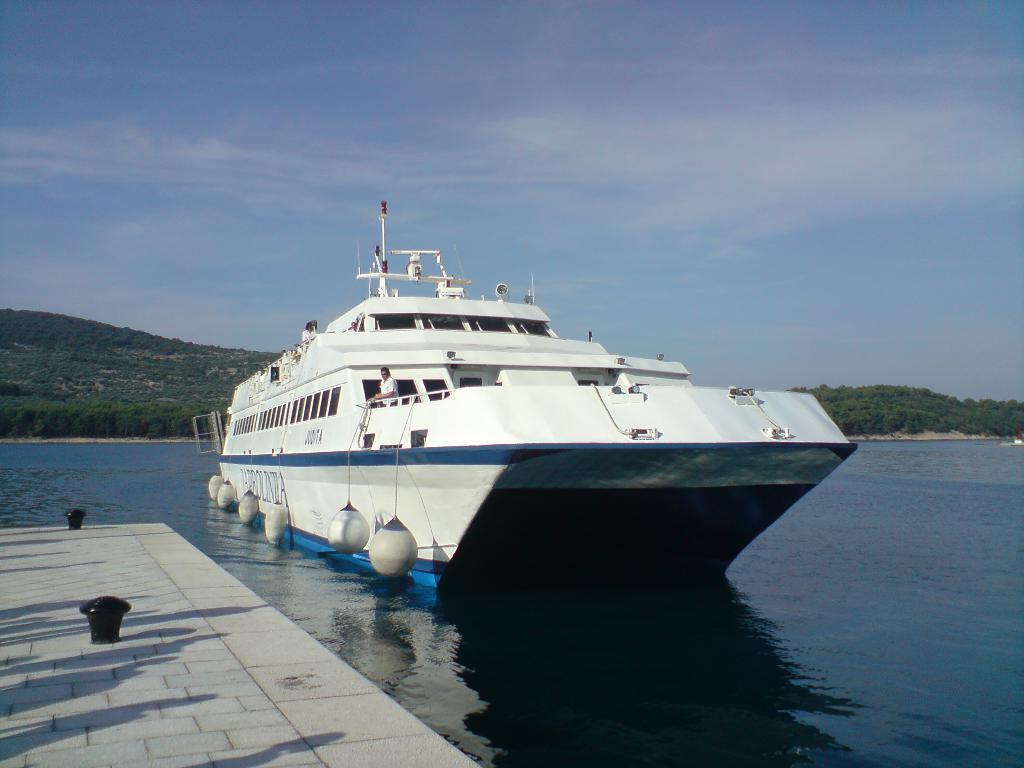In one or two sentences, can you explain what this image depicts? In this picture there is a ship in the center of the image, on the water and there is a dock at the bottom side of the image, there is greenery in the background area of the image. 